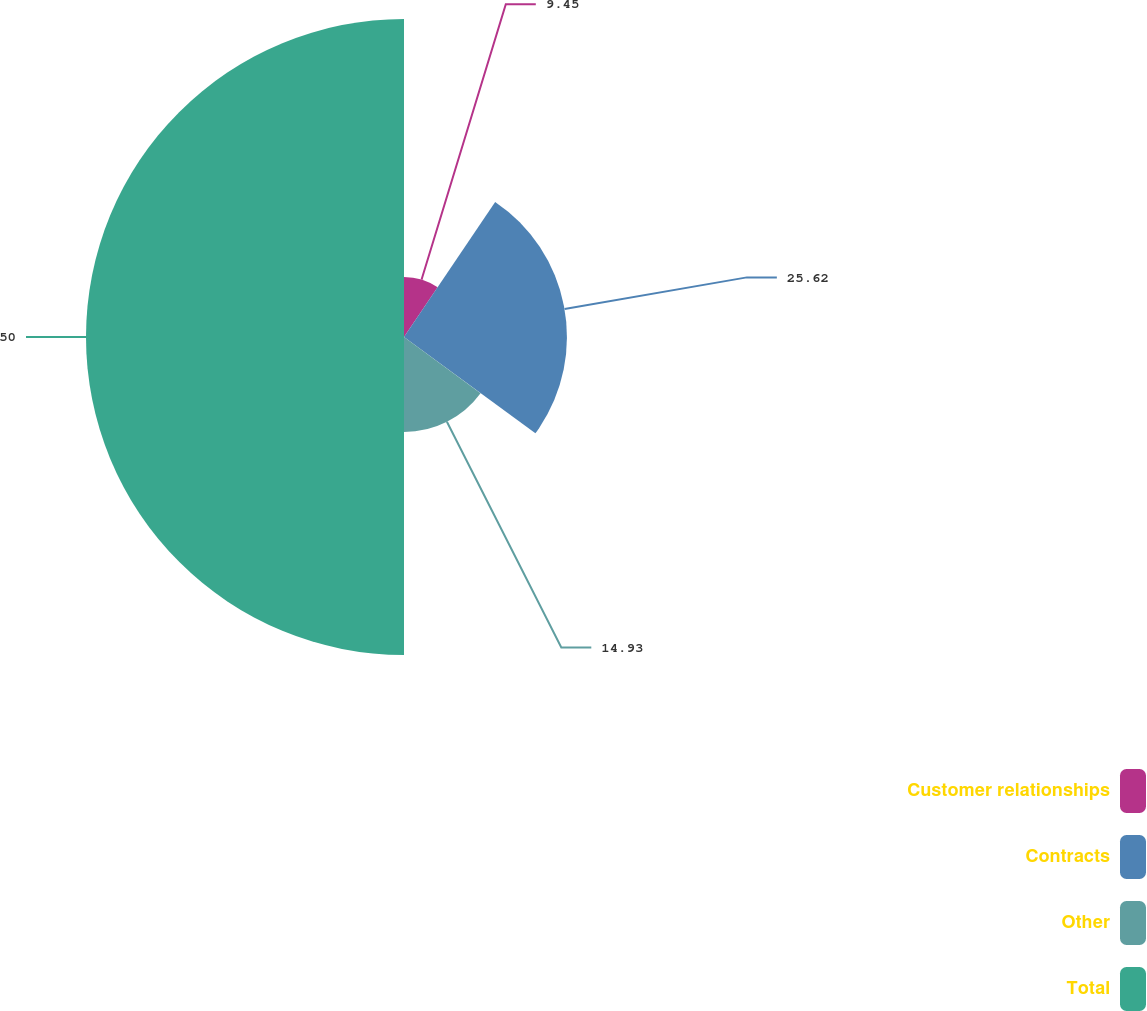<chart> <loc_0><loc_0><loc_500><loc_500><pie_chart><fcel>Customer relationships<fcel>Contracts<fcel>Other<fcel>Total<nl><fcel>9.45%<fcel>25.62%<fcel>14.93%<fcel>50.0%<nl></chart> 